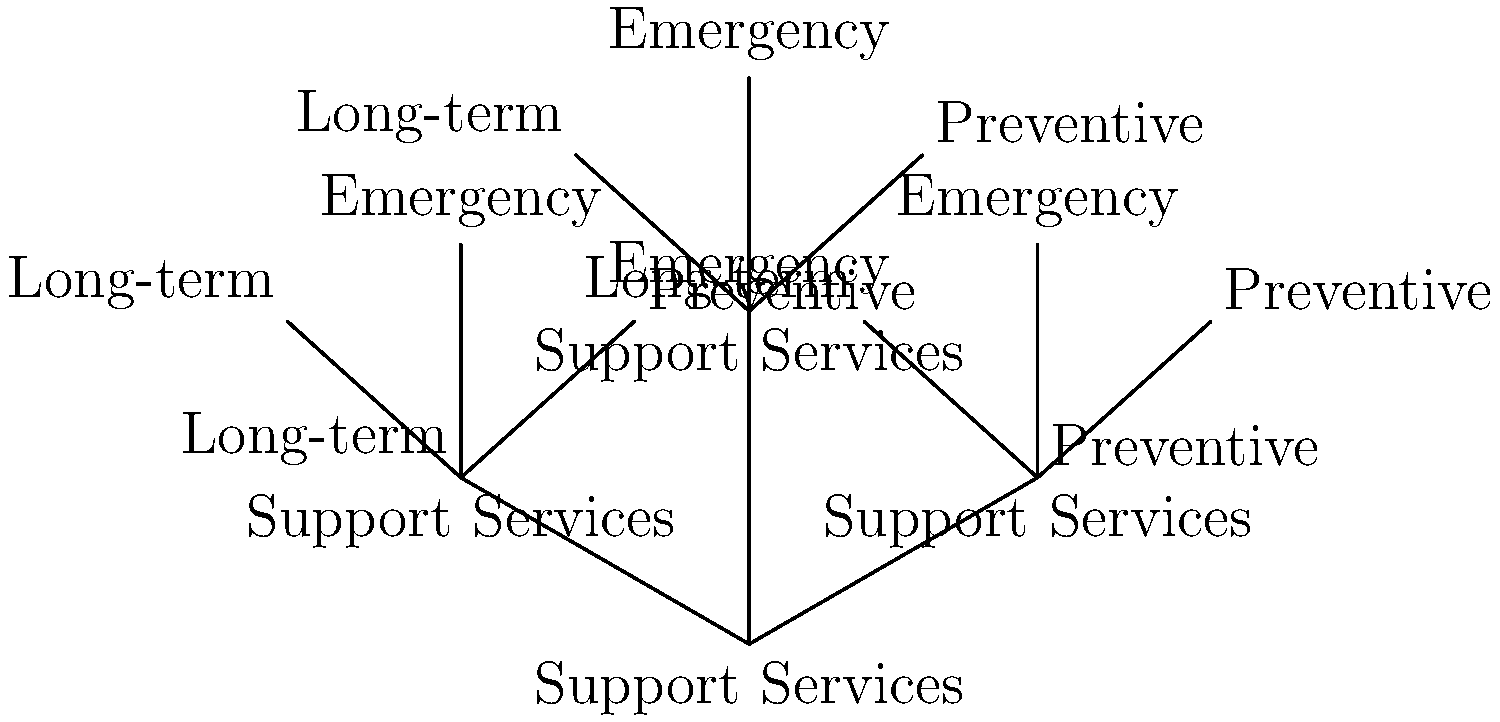In the hierarchy of support services shown in the tree diagram, which branch represents the type of assistance that aims to address issues before they escalate into crises? To answer this question, let's analyze the tree diagram step-by-step:

1. The main trunk of the tree is labeled "Support Services," indicating that this is the overarching category.

2. From the main trunk, three primary branches emerge, representing different types of support services:
   a) Emergency
   b) Long-term
   c) Preventive

3. Each of these branches further divides into smaller sub-branches, suggesting more specific services within each category.

4. The question asks about services that aim to address issues before they escalate into crises.

5. Among the three main branches, "Preventive" services are designed to intervene early and stop problems from developing into more serious situations.

6. Emergency services typically respond to immediate crises, while long-term services address ongoing needs. Neither of these focuses on preventing issues before they become critical.

7. Therefore, the branch that represents assistance aimed at addressing issues before they escalate into crises is the "Preventive" branch.
Answer: Preventive 